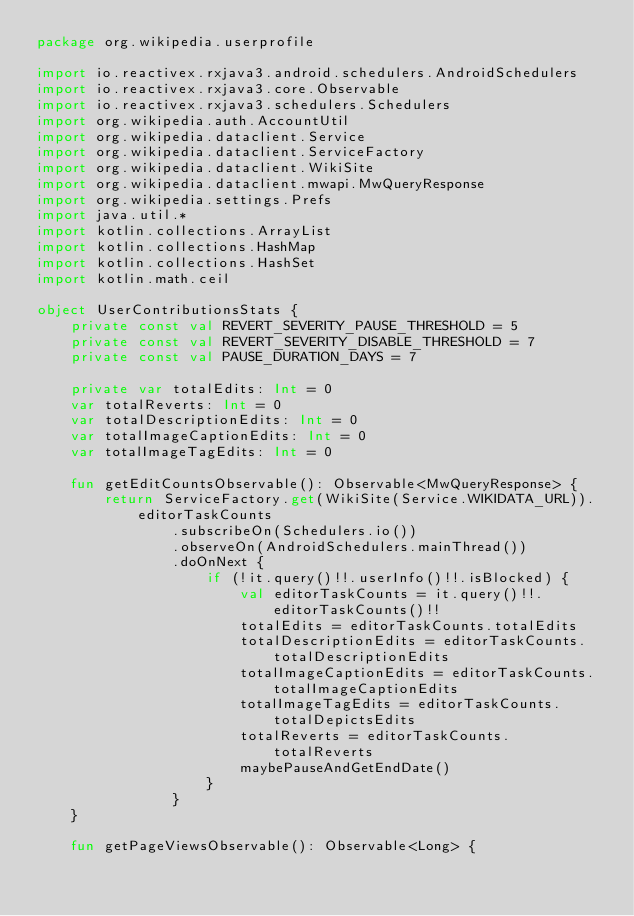Convert code to text. <code><loc_0><loc_0><loc_500><loc_500><_Kotlin_>package org.wikipedia.userprofile

import io.reactivex.rxjava3.android.schedulers.AndroidSchedulers
import io.reactivex.rxjava3.core.Observable
import io.reactivex.rxjava3.schedulers.Schedulers
import org.wikipedia.auth.AccountUtil
import org.wikipedia.dataclient.Service
import org.wikipedia.dataclient.ServiceFactory
import org.wikipedia.dataclient.WikiSite
import org.wikipedia.dataclient.mwapi.MwQueryResponse
import org.wikipedia.settings.Prefs
import java.util.*
import kotlin.collections.ArrayList
import kotlin.collections.HashMap
import kotlin.collections.HashSet
import kotlin.math.ceil

object UserContributionsStats {
    private const val REVERT_SEVERITY_PAUSE_THRESHOLD = 5
    private const val REVERT_SEVERITY_DISABLE_THRESHOLD = 7
    private const val PAUSE_DURATION_DAYS = 7

    private var totalEdits: Int = 0
    var totalReverts: Int = 0
    var totalDescriptionEdits: Int = 0
    var totalImageCaptionEdits: Int = 0
    var totalImageTagEdits: Int = 0

    fun getEditCountsObservable(): Observable<MwQueryResponse> {
        return ServiceFactory.get(WikiSite(Service.WIKIDATA_URL)).editorTaskCounts
                .subscribeOn(Schedulers.io())
                .observeOn(AndroidSchedulers.mainThread())
                .doOnNext {
                    if (!it.query()!!.userInfo()!!.isBlocked) {
                        val editorTaskCounts = it.query()!!.editorTaskCounts()!!
                        totalEdits = editorTaskCounts.totalEdits
                        totalDescriptionEdits = editorTaskCounts.totalDescriptionEdits
                        totalImageCaptionEdits = editorTaskCounts.totalImageCaptionEdits
                        totalImageTagEdits = editorTaskCounts.totalDepictsEdits
                        totalReverts = editorTaskCounts.totalReverts
                        maybePauseAndGetEndDate()
                    }
                }
    }

    fun getPageViewsObservable(): Observable<Long> {</code> 